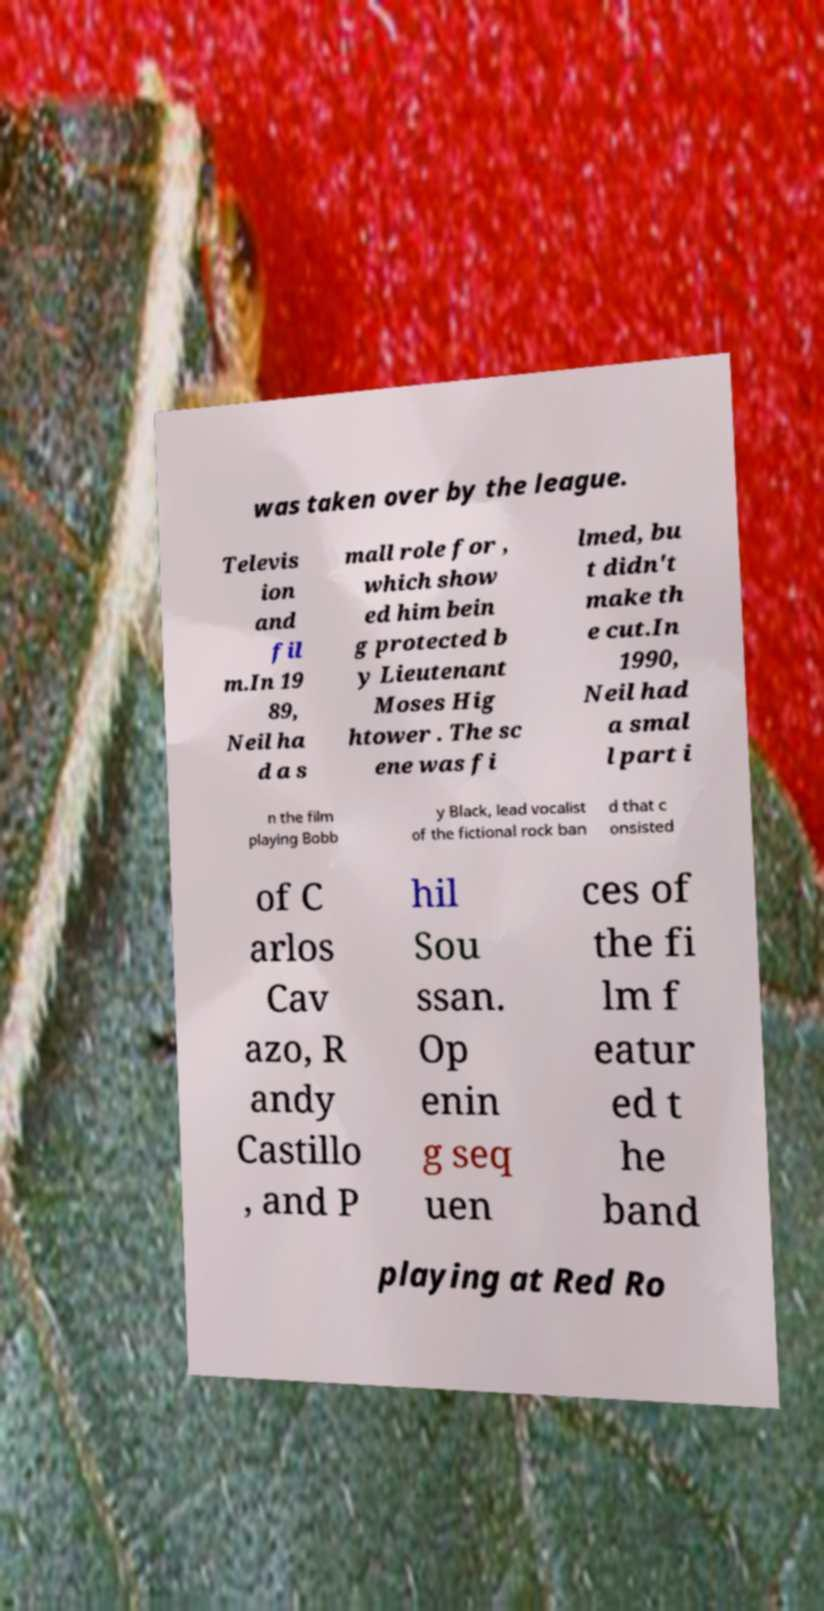Can you accurately transcribe the text from the provided image for me? was taken over by the league. Televis ion and fil m.In 19 89, Neil ha d a s mall role for , which show ed him bein g protected b y Lieutenant Moses Hig htower . The sc ene was fi lmed, bu t didn't make th e cut.In 1990, Neil had a smal l part i n the film playing Bobb y Black, lead vocalist of the fictional rock ban d that c onsisted of C arlos Cav azo, R andy Castillo , and P hil Sou ssan. Op enin g seq uen ces of the fi lm f eatur ed t he band playing at Red Ro 